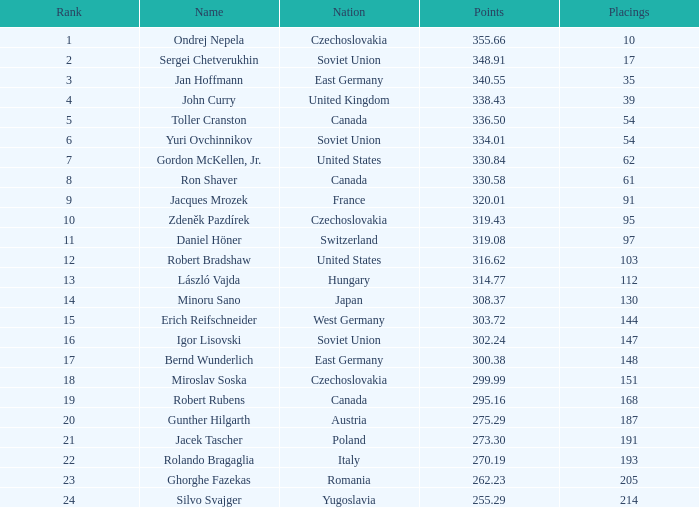Which nation possesses 30 East Germany. 